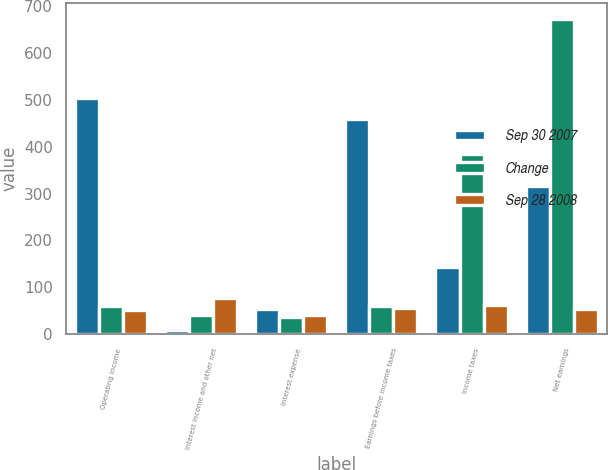Convert chart. <chart><loc_0><loc_0><loc_500><loc_500><stacked_bar_chart><ecel><fcel>Operating income<fcel>Interest income and other net<fcel>Interest expense<fcel>Earnings before income taxes<fcel>Income taxes<fcel>Net earnings<nl><fcel>Sep 30 2007<fcel>503.9<fcel>9<fcel>53.4<fcel>459.5<fcel>144<fcel>315.5<nl><fcel>Change<fcel>59.5<fcel>40.4<fcel>38<fcel>59.5<fcel>383.7<fcel>672.6<nl><fcel>Sep 28 2008<fcel>52.2<fcel>77.7<fcel>40.5<fcel>56.5<fcel>62.5<fcel>53.1<nl></chart> 